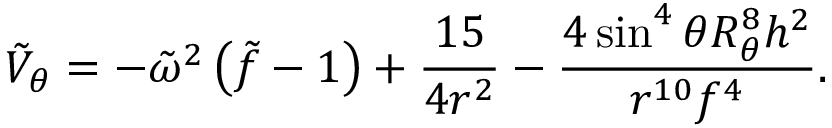<formula> <loc_0><loc_0><loc_500><loc_500>\tilde { V } _ { \theta } = - \tilde { \omega } ^ { 2 } \left ( \tilde { f } - 1 \right ) + { \frac { 1 5 } { 4 r ^ { 2 } } } - { \frac { 4 \sin ^ { 4 } \theta R _ { \theta } ^ { 8 } { h } ^ { 2 } } { r ^ { 1 0 } f ^ { 4 } } } .</formula> 